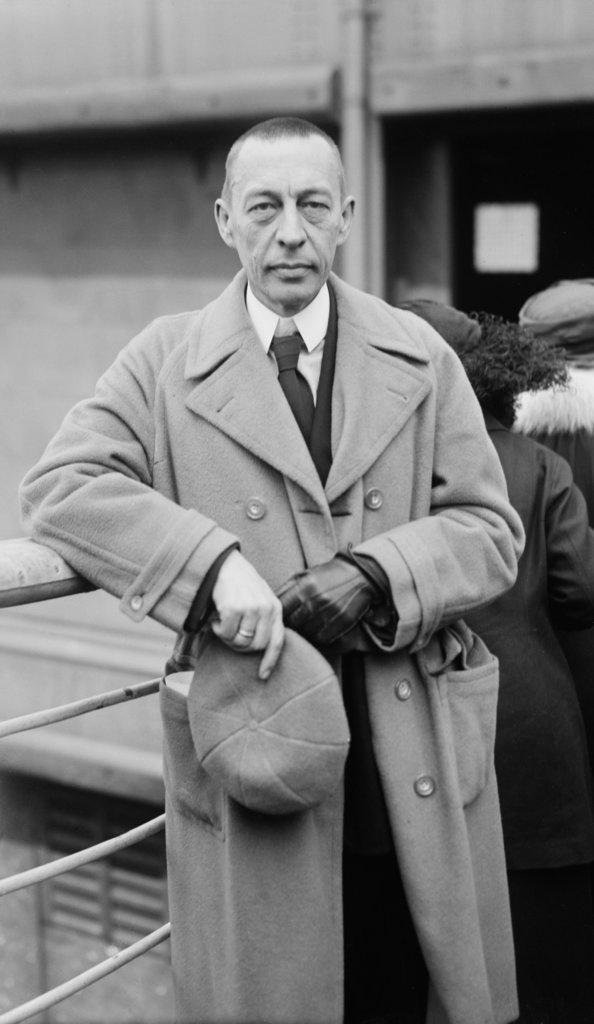What is the color scheme of the image? The image is black and white. How many people are standing on the path in the image? There are three people standing on a path in the image. What is the man holding in the image? The man is holding a cap in the image. What is located behind the people in the image? There is an iron fence behind the people, and a wall behind the iron fence. What type of skirt is the woman wearing in the image? There is no woman wearing a skirt in the image; the people in the image are all men. 